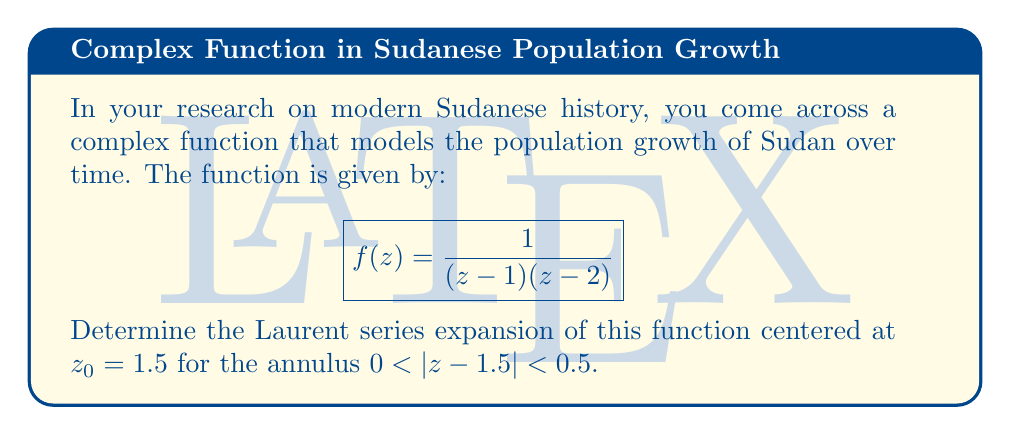Give your solution to this math problem. To find the Laurent series expansion, we follow these steps:

1) First, we rewrite the function in partial fractions:
   $$f(z) = \frac{1}{(z-1)(z-2)} = \frac{1}{z-1} - \frac{1}{z-2}$$

2) Now, we need to expand each term separately around $z_0 = 1.5$:

   For $\frac{1}{z-1}$:
   Let $w = z - 1.5$, so $z - 1 = w + 0.5$
   $$\frac{1}{z-1} = \frac{1}{w+0.5} = \frac{1}{0.5} \cdot \frac{1}{1+\frac{w}{0.5}} = 2 \cdot \frac{1}{1+2w}$$
   
   Using the geometric series formula:
   $$2 \cdot \frac{1}{1+2w} = 2 \sum_{n=0}^{\infty} (-2w)^n = 2 - 4w + 8w^2 - 16w^3 + ...$$

   For $\frac{1}{z-2}$:
   $z - 2 = w - 0.5$
   $$\frac{1}{z-2} = \frac{1}{w-0.5} = -\frac{1}{0.5} \cdot \frac{1}{1-\frac{w}{0.5}} = -2 \cdot \frac{1}{1-2w}$$
   
   $$-2 \cdot \frac{1}{1-2w} = -2 \sum_{n=0}^{\infty} (2w)^n = -2 - 4w - 8w^2 - 16w^3 - ...$$

3) Combining these expansions:
   $$f(z) = (2 - 4w + 8w^2 - 16w^3 + ...) - (-2 - 4w - 8w^2 - 16w^3 - ...)$$
   $$= 4 + 16w^2 + 32w^3 + ...$$

4) Substituting back $w = z - 1.5$:
   $$f(z) = 4 + 16(z-1.5)^2 + 32(z-1.5)^3 + ...$$

This series converges for $0 < |z - 1.5| < 0.5$, which is the given annulus.
Answer: $$f(z) = 4 + 16(z-1.5)^2 + 32(z-1.5)^3 + \sum_{n=4}^{\infty} a_n(z-1.5)^n$$
where $a_n = 2^{n+1}$ for $n \geq 4$ 